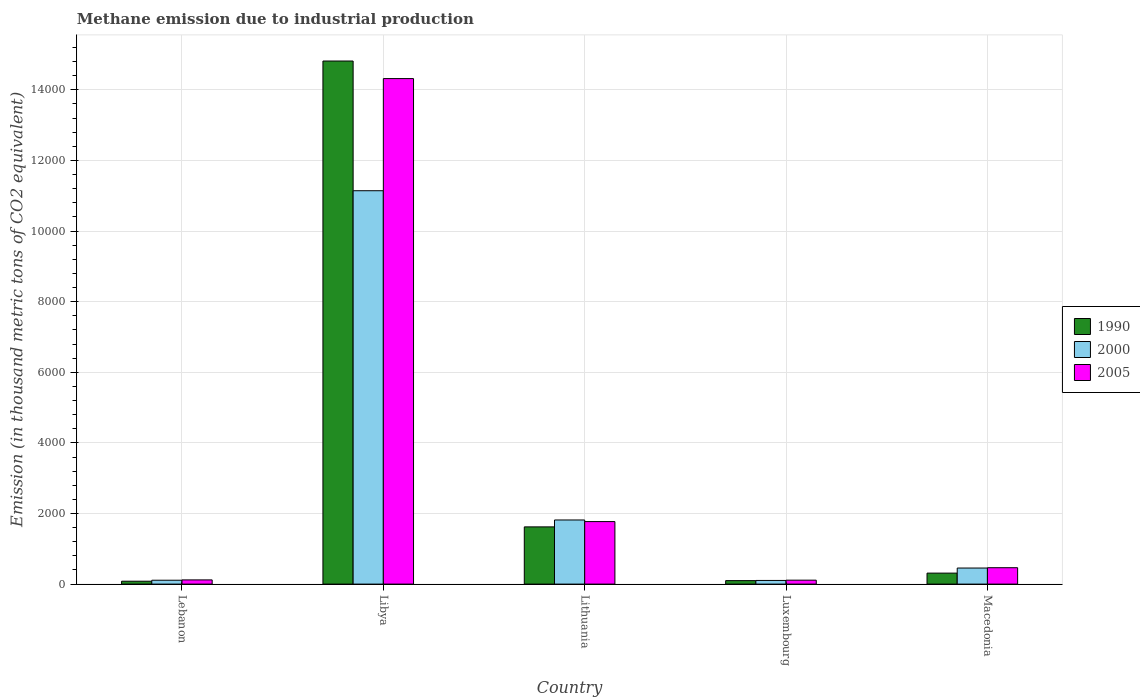How many different coloured bars are there?
Offer a terse response. 3. Are the number of bars on each tick of the X-axis equal?
Give a very brief answer. Yes. What is the label of the 2nd group of bars from the left?
Make the answer very short. Libya. What is the amount of methane emitted in 2005 in Lithuania?
Offer a terse response. 1770.9. Across all countries, what is the maximum amount of methane emitted in 2000?
Make the answer very short. 1.11e+04. Across all countries, what is the minimum amount of methane emitted in 2000?
Keep it short and to the point. 103.7. In which country was the amount of methane emitted in 2005 maximum?
Provide a short and direct response. Libya. In which country was the amount of methane emitted in 2005 minimum?
Offer a terse response. Luxembourg. What is the total amount of methane emitted in 2000 in the graph?
Ensure brevity in your answer.  1.36e+04. What is the difference between the amount of methane emitted in 2005 in Lithuania and that in Macedonia?
Make the answer very short. 1306.7. What is the difference between the amount of methane emitted in 2005 in Lebanon and the amount of methane emitted in 2000 in Lithuania?
Offer a terse response. -1697.5. What is the average amount of methane emitted in 1990 per country?
Give a very brief answer. 3385.6. What is the difference between the amount of methane emitted of/in 2005 and amount of methane emitted of/in 2000 in Lebanon?
Offer a terse response. 9.3. What is the ratio of the amount of methane emitted in 1990 in Lebanon to that in Luxembourg?
Give a very brief answer. 0.83. Is the amount of methane emitted in 1990 in Lebanon less than that in Libya?
Make the answer very short. Yes. Is the difference between the amount of methane emitted in 2005 in Luxembourg and Macedonia greater than the difference between the amount of methane emitted in 2000 in Luxembourg and Macedonia?
Your response must be concise. No. What is the difference between the highest and the second highest amount of methane emitted in 1990?
Provide a succinct answer. 1309.9. What is the difference between the highest and the lowest amount of methane emitted in 2000?
Provide a succinct answer. 1.10e+04. What does the 3rd bar from the left in Luxembourg represents?
Your answer should be compact. 2005. Is it the case that in every country, the sum of the amount of methane emitted in 1990 and amount of methane emitted in 2000 is greater than the amount of methane emitted in 2005?
Your answer should be very brief. Yes. How many bars are there?
Keep it short and to the point. 15. How many countries are there in the graph?
Offer a terse response. 5. What is the difference between two consecutive major ticks on the Y-axis?
Keep it short and to the point. 2000. Does the graph contain any zero values?
Your answer should be very brief. No. Does the graph contain grids?
Your answer should be very brief. Yes. How are the legend labels stacked?
Provide a short and direct response. Vertical. What is the title of the graph?
Keep it short and to the point. Methane emission due to industrial production. What is the label or title of the Y-axis?
Offer a terse response. Emission (in thousand metric tons of CO2 equivalent). What is the Emission (in thousand metric tons of CO2 equivalent) in 1990 in Lebanon?
Make the answer very short. 81.7. What is the Emission (in thousand metric tons of CO2 equivalent) in 2000 in Lebanon?
Make the answer very short. 109.7. What is the Emission (in thousand metric tons of CO2 equivalent) in 2005 in Lebanon?
Your response must be concise. 119. What is the Emission (in thousand metric tons of CO2 equivalent) of 1990 in Libya?
Your answer should be compact. 1.48e+04. What is the Emission (in thousand metric tons of CO2 equivalent) of 2000 in Libya?
Give a very brief answer. 1.11e+04. What is the Emission (in thousand metric tons of CO2 equivalent) of 2005 in Libya?
Your response must be concise. 1.43e+04. What is the Emission (in thousand metric tons of CO2 equivalent) of 1990 in Lithuania?
Give a very brief answer. 1620.9. What is the Emission (in thousand metric tons of CO2 equivalent) in 2000 in Lithuania?
Your response must be concise. 1816.5. What is the Emission (in thousand metric tons of CO2 equivalent) in 2005 in Lithuania?
Offer a terse response. 1770.9. What is the Emission (in thousand metric tons of CO2 equivalent) of 1990 in Luxembourg?
Give a very brief answer. 98.7. What is the Emission (in thousand metric tons of CO2 equivalent) of 2000 in Luxembourg?
Keep it short and to the point. 103.7. What is the Emission (in thousand metric tons of CO2 equivalent) in 2005 in Luxembourg?
Your response must be concise. 111.5. What is the Emission (in thousand metric tons of CO2 equivalent) in 1990 in Macedonia?
Provide a short and direct response. 311. What is the Emission (in thousand metric tons of CO2 equivalent) of 2000 in Macedonia?
Provide a succinct answer. 454.8. What is the Emission (in thousand metric tons of CO2 equivalent) of 2005 in Macedonia?
Offer a terse response. 464.2. Across all countries, what is the maximum Emission (in thousand metric tons of CO2 equivalent) of 1990?
Provide a short and direct response. 1.48e+04. Across all countries, what is the maximum Emission (in thousand metric tons of CO2 equivalent) of 2000?
Offer a terse response. 1.11e+04. Across all countries, what is the maximum Emission (in thousand metric tons of CO2 equivalent) in 2005?
Make the answer very short. 1.43e+04. Across all countries, what is the minimum Emission (in thousand metric tons of CO2 equivalent) of 1990?
Ensure brevity in your answer.  81.7. Across all countries, what is the minimum Emission (in thousand metric tons of CO2 equivalent) in 2000?
Your answer should be very brief. 103.7. Across all countries, what is the minimum Emission (in thousand metric tons of CO2 equivalent) in 2005?
Offer a very short reply. 111.5. What is the total Emission (in thousand metric tons of CO2 equivalent) in 1990 in the graph?
Ensure brevity in your answer.  1.69e+04. What is the total Emission (in thousand metric tons of CO2 equivalent) in 2000 in the graph?
Offer a very short reply. 1.36e+04. What is the total Emission (in thousand metric tons of CO2 equivalent) in 2005 in the graph?
Make the answer very short. 1.68e+04. What is the difference between the Emission (in thousand metric tons of CO2 equivalent) of 1990 in Lebanon and that in Libya?
Your response must be concise. -1.47e+04. What is the difference between the Emission (in thousand metric tons of CO2 equivalent) in 2000 in Lebanon and that in Libya?
Your response must be concise. -1.10e+04. What is the difference between the Emission (in thousand metric tons of CO2 equivalent) of 2005 in Lebanon and that in Libya?
Keep it short and to the point. -1.42e+04. What is the difference between the Emission (in thousand metric tons of CO2 equivalent) in 1990 in Lebanon and that in Lithuania?
Your answer should be compact. -1539.2. What is the difference between the Emission (in thousand metric tons of CO2 equivalent) of 2000 in Lebanon and that in Lithuania?
Give a very brief answer. -1706.8. What is the difference between the Emission (in thousand metric tons of CO2 equivalent) of 2005 in Lebanon and that in Lithuania?
Your answer should be very brief. -1651.9. What is the difference between the Emission (in thousand metric tons of CO2 equivalent) in 1990 in Lebanon and that in Macedonia?
Provide a short and direct response. -229.3. What is the difference between the Emission (in thousand metric tons of CO2 equivalent) of 2000 in Lebanon and that in Macedonia?
Your answer should be compact. -345.1. What is the difference between the Emission (in thousand metric tons of CO2 equivalent) of 2005 in Lebanon and that in Macedonia?
Provide a short and direct response. -345.2. What is the difference between the Emission (in thousand metric tons of CO2 equivalent) in 1990 in Libya and that in Lithuania?
Give a very brief answer. 1.32e+04. What is the difference between the Emission (in thousand metric tons of CO2 equivalent) in 2000 in Libya and that in Lithuania?
Give a very brief answer. 9325.5. What is the difference between the Emission (in thousand metric tons of CO2 equivalent) of 2005 in Libya and that in Lithuania?
Give a very brief answer. 1.25e+04. What is the difference between the Emission (in thousand metric tons of CO2 equivalent) of 1990 in Libya and that in Luxembourg?
Keep it short and to the point. 1.47e+04. What is the difference between the Emission (in thousand metric tons of CO2 equivalent) in 2000 in Libya and that in Luxembourg?
Provide a succinct answer. 1.10e+04. What is the difference between the Emission (in thousand metric tons of CO2 equivalent) in 2005 in Libya and that in Luxembourg?
Provide a short and direct response. 1.42e+04. What is the difference between the Emission (in thousand metric tons of CO2 equivalent) in 1990 in Libya and that in Macedonia?
Your response must be concise. 1.45e+04. What is the difference between the Emission (in thousand metric tons of CO2 equivalent) in 2000 in Libya and that in Macedonia?
Provide a short and direct response. 1.07e+04. What is the difference between the Emission (in thousand metric tons of CO2 equivalent) of 2005 in Libya and that in Macedonia?
Your answer should be very brief. 1.39e+04. What is the difference between the Emission (in thousand metric tons of CO2 equivalent) in 1990 in Lithuania and that in Luxembourg?
Your response must be concise. 1522.2. What is the difference between the Emission (in thousand metric tons of CO2 equivalent) in 2000 in Lithuania and that in Luxembourg?
Make the answer very short. 1712.8. What is the difference between the Emission (in thousand metric tons of CO2 equivalent) of 2005 in Lithuania and that in Luxembourg?
Offer a very short reply. 1659.4. What is the difference between the Emission (in thousand metric tons of CO2 equivalent) of 1990 in Lithuania and that in Macedonia?
Keep it short and to the point. 1309.9. What is the difference between the Emission (in thousand metric tons of CO2 equivalent) of 2000 in Lithuania and that in Macedonia?
Provide a succinct answer. 1361.7. What is the difference between the Emission (in thousand metric tons of CO2 equivalent) in 2005 in Lithuania and that in Macedonia?
Your answer should be very brief. 1306.7. What is the difference between the Emission (in thousand metric tons of CO2 equivalent) in 1990 in Luxembourg and that in Macedonia?
Ensure brevity in your answer.  -212.3. What is the difference between the Emission (in thousand metric tons of CO2 equivalent) of 2000 in Luxembourg and that in Macedonia?
Offer a very short reply. -351.1. What is the difference between the Emission (in thousand metric tons of CO2 equivalent) of 2005 in Luxembourg and that in Macedonia?
Give a very brief answer. -352.7. What is the difference between the Emission (in thousand metric tons of CO2 equivalent) of 1990 in Lebanon and the Emission (in thousand metric tons of CO2 equivalent) of 2000 in Libya?
Offer a terse response. -1.11e+04. What is the difference between the Emission (in thousand metric tons of CO2 equivalent) of 1990 in Lebanon and the Emission (in thousand metric tons of CO2 equivalent) of 2005 in Libya?
Provide a short and direct response. -1.42e+04. What is the difference between the Emission (in thousand metric tons of CO2 equivalent) of 2000 in Lebanon and the Emission (in thousand metric tons of CO2 equivalent) of 2005 in Libya?
Provide a short and direct response. -1.42e+04. What is the difference between the Emission (in thousand metric tons of CO2 equivalent) of 1990 in Lebanon and the Emission (in thousand metric tons of CO2 equivalent) of 2000 in Lithuania?
Your answer should be compact. -1734.8. What is the difference between the Emission (in thousand metric tons of CO2 equivalent) in 1990 in Lebanon and the Emission (in thousand metric tons of CO2 equivalent) in 2005 in Lithuania?
Offer a very short reply. -1689.2. What is the difference between the Emission (in thousand metric tons of CO2 equivalent) of 2000 in Lebanon and the Emission (in thousand metric tons of CO2 equivalent) of 2005 in Lithuania?
Make the answer very short. -1661.2. What is the difference between the Emission (in thousand metric tons of CO2 equivalent) in 1990 in Lebanon and the Emission (in thousand metric tons of CO2 equivalent) in 2005 in Luxembourg?
Your answer should be compact. -29.8. What is the difference between the Emission (in thousand metric tons of CO2 equivalent) of 2000 in Lebanon and the Emission (in thousand metric tons of CO2 equivalent) of 2005 in Luxembourg?
Your answer should be very brief. -1.8. What is the difference between the Emission (in thousand metric tons of CO2 equivalent) in 1990 in Lebanon and the Emission (in thousand metric tons of CO2 equivalent) in 2000 in Macedonia?
Your response must be concise. -373.1. What is the difference between the Emission (in thousand metric tons of CO2 equivalent) in 1990 in Lebanon and the Emission (in thousand metric tons of CO2 equivalent) in 2005 in Macedonia?
Offer a terse response. -382.5. What is the difference between the Emission (in thousand metric tons of CO2 equivalent) of 2000 in Lebanon and the Emission (in thousand metric tons of CO2 equivalent) of 2005 in Macedonia?
Make the answer very short. -354.5. What is the difference between the Emission (in thousand metric tons of CO2 equivalent) in 1990 in Libya and the Emission (in thousand metric tons of CO2 equivalent) in 2000 in Lithuania?
Provide a succinct answer. 1.30e+04. What is the difference between the Emission (in thousand metric tons of CO2 equivalent) of 1990 in Libya and the Emission (in thousand metric tons of CO2 equivalent) of 2005 in Lithuania?
Keep it short and to the point. 1.30e+04. What is the difference between the Emission (in thousand metric tons of CO2 equivalent) in 2000 in Libya and the Emission (in thousand metric tons of CO2 equivalent) in 2005 in Lithuania?
Offer a very short reply. 9371.1. What is the difference between the Emission (in thousand metric tons of CO2 equivalent) in 1990 in Libya and the Emission (in thousand metric tons of CO2 equivalent) in 2000 in Luxembourg?
Your answer should be compact. 1.47e+04. What is the difference between the Emission (in thousand metric tons of CO2 equivalent) in 1990 in Libya and the Emission (in thousand metric tons of CO2 equivalent) in 2005 in Luxembourg?
Make the answer very short. 1.47e+04. What is the difference between the Emission (in thousand metric tons of CO2 equivalent) of 2000 in Libya and the Emission (in thousand metric tons of CO2 equivalent) of 2005 in Luxembourg?
Offer a terse response. 1.10e+04. What is the difference between the Emission (in thousand metric tons of CO2 equivalent) in 1990 in Libya and the Emission (in thousand metric tons of CO2 equivalent) in 2000 in Macedonia?
Offer a very short reply. 1.44e+04. What is the difference between the Emission (in thousand metric tons of CO2 equivalent) of 1990 in Libya and the Emission (in thousand metric tons of CO2 equivalent) of 2005 in Macedonia?
Your response must be concise. 1.44e+04. What is the difference between the Emission (in thousand metric tons of CO2 equivalent) in 2000 in Libya and the Emission (in thousand metric tons of CO2 equivalent) in 2005 in Macedonia?
Provide a succinct answer. 1.07e+04. What is the difference between the Emission (in thousand metric tons of CO2 equivalent) of 1990 in Lithuania and the Emission (in thousand metric tons of CO2 equivalent) of 2000 in Luxembourg?
Ensure brevity in your answer.  1517.2. What is the difference between the Emission (in thousand metric tons of CO2 equivalent) of 1990 in Lithuania and the Emission (in thousand metric tons of CO2 equivalent) of 2005 in Luxembourg?
Your answer should be very brief. 1509.4. What is the difference between the Emission (in thousand metric tons of CO2 equivalent) of 2000 in Lithuania and the Emission (in thousand metric tons of CO2 equivalent) of 2005 in Luxembourg?
Make the answer very short. 1705. What is the difference between the Emission (in thousand metric tons of CO2 equivalent) in 1990 in Lithuania and the Emission (in thousand metric tons of CO2 equivalent) in 2000 in Macedonia?
Make the answer very short. 1166.1. What is the difference between the Emission (in thousand metric tons of CO2 equivalent) in 1990 in Lithuania and the Emission (in thousand metric tons of CO2 equivalent) in 2005 in Macedonia?
Offer a terse response. 1156.7. What is the difference between the Emission (in thousand metric tons of CO2 equivalent) of 2000 in Lithuania and the Emission (in thousand metric tons of CO2 equivalent) of 2005 in Macedonia?
Make the answer very short. 1352.3. What is the difference between the Emission (in thousand metric tons of CO2 equivalent) of 1990 in Luxembourg and the Emission (in thousand metric tons of CO2 equivalent) of 2000 in Macedonia?
Ensure brevity in your answer.  -356.1. What is the difference between the Emission (in thousand metric tons of CO2 equivalent) in 1990 in Luxembourg and the Emission (in thousand metric tons of CO2 equivalent) in 2005 in Macedonia?
Provide a short and direct response. -365.5. What is the difference between the Emission (in thousand metric tons of CO2 equivalent) of 2000 in Luxembourg and the Emission (in thousand metric tons of CO2 equivalent) of 2005 in Macedonia?
Provide a short and direct response. -360.5. What is the average Emission (in thousand metric tons of CO2 equivalent) of 1990 per country?
Your answer should be compact. 3385.6. What is the average Emission (in thousand metric tons of CO2 equivalent) in 2000 per country?
Ensure brevity in your answer.  2725.34. What is the average Emission (in thousand metric tons of CO2 equivalent) of 2005 per country?
Provide a succinct answer. 3356.84. What is the difference between the Emission (in thousand metric tons of CO2 equivalent) in 1990 and Emission (in thousand metric tons of CO2 equivalent) in 2000 in Lebanon?
Provide a succinct answer. -28. What is the difference between the Emission (in thousand metric tons of CO2 equivalent) in 1990 and Emission (in thousand metric tons of CO2 equivalent) in 2005 in Lebanon?
Ensure brevity in your answer.  -37.3. What is the difference between the Emission (in thousand metric tons of CO2 equivalent) of 2000 and Emission (in thousand metric tons of CO2 equivalent) of 2005 in Lebanon?
Offer a very short reply. -9.3. What is the difference between the Emission (in thousand metric tons of CO2 equivalent) of 1990 and Emission (in thousand metric tons of CO2 equivalent) of 2000 in Libya?
Your answer should be compact. 3673.7. What is the difference between the Emission (in thousand metric tons of CO2 equivalent) in 1990 and Emission (in thousand metric tons of CO2 equivalent) in 2005 in Libya?
Provide a succinct answer. 497.1. What is the difference between the Emission (in thousand metric tons of CO2 equivalent) in 2000 and Emission (in thousand metric tons of CO2 equivalent) in 2005 in Libya?
Offer a terse response. -3176.6. What is the difference between the Emission (in thousand metric tons of CO2 equivalent) of 1990 and Emission (in thousand metric tons of CO2 equivalent) of 2000 in Lithuania?
Offer a very short reply. -195.6. What is the difference between the Emission (in thousand metric tons of CO2 equivalent) in 1990 and Emission (in thousand metric tons of CO2 equivalent) in 2005 in Lithuania?
Keep it short and to the point. -150. What is the difference between the Emission (in thousand metric tons of CO2 equivalent) of 2000 and Emission (in thousand metric tons of CO2 equivalent) of 2005 in Lithuania?
Give a very brief answer. 45.6. What is the difference between the Emission (in thousand metric tons of CO2 equivalent) in 1990 and Emission (in thousand metric tons of CO2 equivalent) in 2000 in Luxembourg?
Offer a terse response. -5. What is the difference between the Emission (in thousand metric tons of CO2 equivalent) in 1990 and Emission (in thousand metric tons of CO2 equivalent) in 2005 in Luxembourg?
Your answer should be very brief. -12.8. What is the difference between the Emission (in thousand metric tons of CO2 equivalent) of 1990 and Emission (in thousand metric tons of CO2 equivalent) of 2000 in Macedonia?
Offer a terse response. -143.8. What is the difference between the Emission (in thousand metric tons of CO2 equivalent) in 1990 and Emission (in thousand metric tons of CO2 equivalent) in 2005 in Macedonia?
Provide a short and direct response. -153.2. What is the ratio of the Emission (in thousand metric tons of CO2 equivalent) of 1990 in Lebanon to that in Libya?
Give a very brief answer. 0.01. What is the ratio of the Emission (in thousand metric tons of CO2 equivalent) of 2000 in Lebanon to that in Libya?
Provide a succinct answer. 0.01. What is the ratio of the Emission (in thousand metric tons of CO2 equivalent) in 2005 in Lebanon to that in Libya?
Provide a succinct answer. 0.01. What is the ratio of the Emission (in thousand metric tons of CO2 equivalent) in 1990 in Lebanon to that in Lithuania?
Your answer should be very brief. 0.05. What is the ratio of the Emission (in thousand metric tons of CO2 equivalent) of 2000 in Lebanon to that in Lithuania?
Give a very brief answer. 0.06. What is the ratio of the Emission (in thousand metric tons of CO2 equivalent) in 2005 in Lebanon to that in Lithuania?
Provide a succinct answer. 0.07. What is the ratio of the Emission (in thousand metric tons of CO2 equivalent) of 1990 in Lebanon to that in Luxembourg?
Provide a succinct answer. 0.83. What is the ratio of the Emission (in thousand metric tons of CO2 equivalent) in 2000 in Lebanon to that in Luxembourg?
Give a very brief answer. 1.06. What is the ratio of the Emission (in thousand metric tons of CO2 equivalent) in 2005 in Lebanon to that in Luxembourg?
Make the answer very short. 1.07. What is the ratio of the Emission (in thousand metric tons of CO2 equivalent) in 1990 in Lebanon to that in Macedonia?
Your answer should be very brief. 0.26. What is the ratio of the Emission (in thousand metric tons of CO2 equivalent) of 2000 in Lebanon to that in Macedonia?
Your answer should be compact. 0.24. What is the ratio of the Emission (in thousand metric tons of CO2 equivalent) of 2005 in Lebanon to that in Macedonia?
Offer a very short reply. 0.26. What is the ratio of the Emission (in thousand metric tons of CO2 equivalent) of 1990 in Libya to that in Lithuania?
Your response must be concise. 9.14. What is the ratio of the Emission (in thousand metric tons of CO2 equivalent) of 2000 in Libya to that in Lithuania?
Offer a very short reply. 6.13. What is the ratio of the Emission (in thousand metric tons of CO2 equivalent) in 2005 in Libya to that in Lithuania?
Keep it short and to the point. 8.09. What is the ratio of the Emission (in thousand metric tons of CO2 equivalent) of 1990 in Libya to that in Luxembourg?
Offer a very short reply. 150.11. What is the ratio of the Emission (in thousand metric tons of CO2 equivalent) in 2000 in Libya to that in Luxembourg?
Your answer should be compact. 107.44. What is the ratio of the Emission (in thousand metric tons of CO2 equivalent) in 2005 in Libya to that in Luxembourg?
Keep it short and to the point. 128.42. What is the ratio of the Emission (in thousand metric tons of CO2 equivalent) of 1990 in Libya to that in Macedonia?
Give a very brief answer. 47.64. What is the ratio of the Emission (in thousand metric tons of CO2 equivalent) in 2000 in Libya to that in Macedonia?
Offer a very short reply. 24.5. What is the ratio of the Emission (in thousand metric tons of CO2 equivalent) of 2005 in Libya to that in Macedonia?
Make the answer very short. 30.85. What is the ratio of the Emission (in thousand metric tons of CO2 equivalent) of 1990 in Lithuania to that in Luxembourg?
Your response must be concise. 16.42. What is the ratio of the Emission (in thousand metric tons of CO2 equivalent) in 2000 in Lithuania to that in Luxembourg?
Ensure brevity in your answer.  17.52. What is the ratio of the Emission (in thousand metric tons of CO2 equivalent) of 2005 in Lithuania to that in Luxembourg?
Give a very brief answer. 15.88. What is the ratio of the Emission (in thousand metric tons of CO2 equivalent) in 1990 in Lithuania to that in Macedonia?
Provide a short and direct response. 5.21. What is the ratio of the Emission (in thousand metric tons of CO2 equivalent) in 2000 in Lithuania to that in Macedonia?
Make the answer very short. 3.99. What is the ratio of the Emission (in thousand metric tons of CO2 equivalent) of 2005 in Lithuania to that in Macedonia?
Provide a short and direct response. 3.81. What is the ratio of the Emission (in thousand metric tons of CO2 equivalent) in 1990 in Luxembourg to that in Macedonia?
Provide a short and direct response. 0.32. What is the ratio of the Emission (in thousand metric tons of CO2 equivalent) in 2000 in Luxembourg to that in Macedonia?
Provide a succinct answer. 0.23. What is the ratio of the Emission (in thousand metric tons of CO2 equivalent) of 2005 in Luxembourg to that in Macedonia?
Ensure brevity in your answer.  0.24. What is the difference between the highest and the second highest Emission (in thousand metric tons of CO2 equivalent) in 1990?
Provide a succinct answer. 1.32e+04. What is the difference between the highest and the second highest Emission (in thousand metric tons of CO2 equivalent) in 2000?
Provide a succinct answer. 9325.5. What is the difference between the highest and the second highest Emission (in thousand metric tons of CO2 equivalent) in 2005?
Provide a short and direct response. 1.25e+04. What is the difference between the highest and the lowest Emission (in thousand metric tons of CO2 equivalent) of 1990?
Offer a terse response. 1.47e+04. What is the difference between the highest and the lowest Emission (in thousand metric tons of CO2 equivalent) of 2000?
Provide a short and direct response. 1.10e+04. What is the difference between the highest and the lowest Emission (in thousand metric tons of CO2 equivalent) in 2005?
Give a very brief answer. 1.42e+04. 